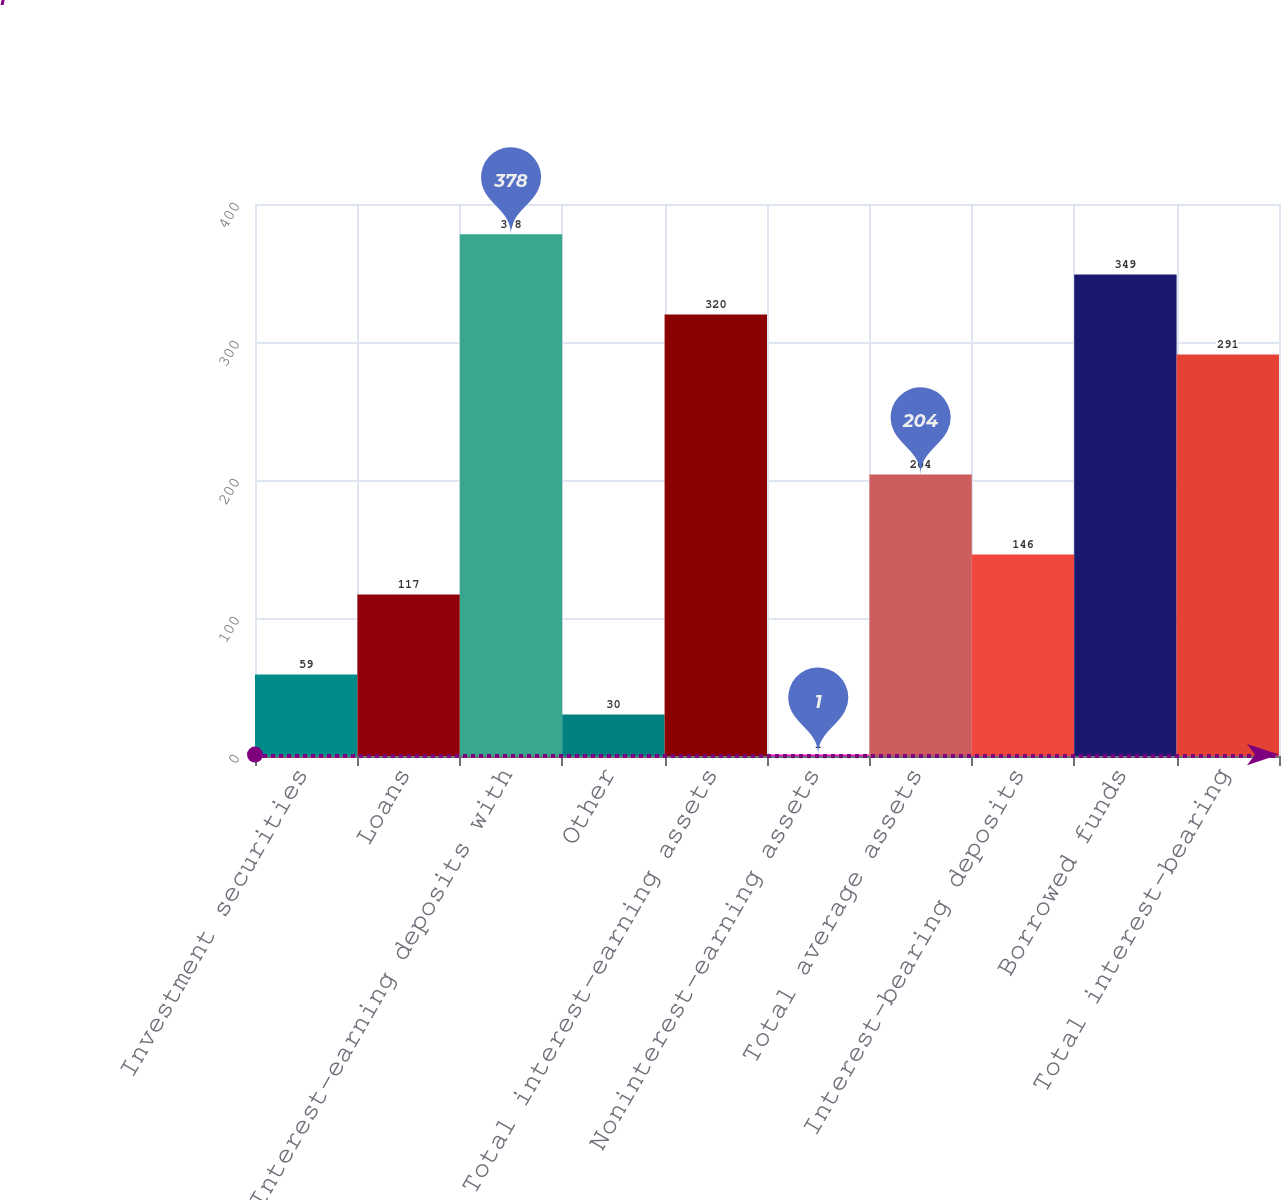Convert chart to OTSL. <chart><loc_0><loc_0><loc_500><loc_500><bar_chart><fcel>Investment securities<fcel>Loans<fcel>Interest-earning deposits with<fcel>Other<fcel>Total interest-earning assets<fcel>Noninterest-earning assets<fcel>Total average assets<fcel>Interest-bearing deposits<fcel>Borrowed funds<fcel>Total interest-bearing<nl><fcel>59<fcel>117<fcel>378<fcel>30<fcel>320<fcel>1<fcel>204<fcel>146<fcel>349<fcel>291<nl></chart> 